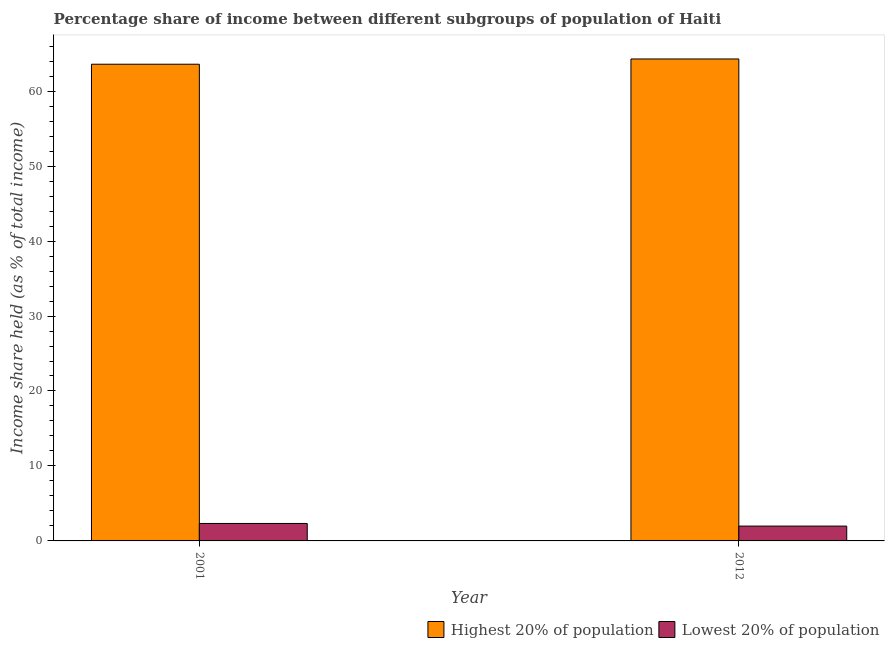How many bars are there on the 2nd tick from the left?
Provide a succinct answer. 2. How many bars are there on the 2nd tick from the right?
Provide a succinct answer. 2. What is the label of the 2nd group of bars from the left?
Your answer should be compact. 2012. In how many cases, is the number of bars for a given year not equal to the number of legend labels?
Offer a terse response. 0. What is the income share held by lowest 20% of the population in 2001?
Keep it short and to the point. 2.33. Across all years, what is the maximum income share held by lowest 20% of the population?
Your answer should be very brief. 2.33. Across all years, what is the minimum income share held by highest 20% of the population?
Keep it short and to the point. 63.59. In which year was the income share held by lowest 20% of the population maximum?
Your answer should be compact. 2001. In which year was the income share held by highest 20% of the population minimum?
Your answer should be compact. 2001. What is the total income share held by highest 20% of the population in the graph?
Your answer should be very brief. 127.88. What is the difference between the income share held by highest 20% of the population in 2001 and that in 2012?
Make the answer very short. -0.7. What is the difference between the income share held by lowest 20% of the population in 2001 and the income share held by highest 20% of the population in 2012?
Your response must be concise. 0.35. What is the average income share held by lowest 20% of the population per year?
Provide a succinct answer. 2.16. In the year 2012, what is the difference between the income share held by lowest 20% of the population and income share held by highest 20% of the population?
Keep it short and to the point. 0. What is the ratio of the income share held by highest 20% of the population in 2001 to that in 2012?
Provide a short and direct response. 0.99. In how many years, is the income share held by lowest 20% of the population greater than the average income share held by lowest 20% of the population taken over all years?
Your answer should be compact. 1. What does the 1st bar from the left in 2012 represents?
Offer a very short reply. Highest 20% of population. What does the 2nd bar from the right in 2001 represents?
Keep it short and to the point. Highest 20% of population. What is the difference between two consecutive major ticks on the Y-axis?
Make the answer very short. 10. Does the graph contain any zero values?
Offer a terse response. No. Does the graph contain grids?
Your answer should be compact. No. How many legend labels are there?
Provide a succinct answer. 2. What is the title of the graph?
Your answer should be very brief. Percentage share of income between different subgroups of population of Haiti. Does "current US$" appear as one of the legend labels in the graph?
Make the answer very short. No. What is the label or title of the Y-axis?
Provide a succinct answer. Income share held (as % of total income). What is the Income share held (as % of total income) of Highest 20% of population in 2001?
Give a very brief answer. 63.59. What is the Income share held (as % of total income) in Lowest 20% of population in 2001?
Offer a very short reply. 2.33. What is the Income share held (as % of total income) of Highest 20% of population in 2012?
Give a very brief answer. 64.29. What is the Income share held (as % of total income) in Lowest 20% of population in 2012?
Give a very brief answer. 1.98. Across all years, what is the maximum Income share held (as % of total income) in Highest 20% of population?
Make the answer very short. 64.29. Across all years, what is the maximum Income share held (as % of total income) in Lowest 20% of population?
Provide a succinct answer. 2.33. Across all years, what is the minimum Income share held (as % of total income) of Highest 20% of population?
Provide a short and direct response. 63.59. Across all years, what is the minimum Income share held (as % of total income) of Lowest 20% of population?
Offer a terse response. 1.98. What is the total Income share held (as % of total income) in Highest 20% of population in the graph?
Your answer should be compact. 127.88. What is the total Income share held (as % of total income) of Lowest 20% of population in the graph?
Offer a very short reply. 4.31. What is the difference between the Income share held (as % of total income) of Highest 20% of population in 2001 and that in 2012?
Keep it short and to the point. -0.7. What is the difference between the Income share held (as % of total income) in Lowest 20% of population in 2001 and that in 2012?
Make the answer very short. 0.35. What is the difference between the Income share held (as % of total income) of Highest 20% of population in 2001 and the Income share held (as % of total income) of Lowest 20% of population in 2012?
Provide a short and direct response. 61.61. What is the average Income share held (as % of total income) of Highest 20% of population per year?
Offer a very short reply. 63.94. What is the average Income share held (as % of total income) of Lowest 20% of population per year?
Ensure brevity in your answer.  2.15. In the year 2001, what is the difference between the Income share held (as % of total income) of Highest 20% of population and Income share held (as % of total income) of Lowest 20% of population?
Your answer should be compact. 61.26. In the year 2012, what is the difference between the Income share held (as % of total income) in Highest 20% of population and Income share held (as % of total income) in Lowest 20% of population?
Keep it short and to the point. 62.31. What is the ratio of the Income share held (as % of total income) in Lowest 20% of population in 2001 to that in 2012?
Offer a terse response. 1.18. What is the difference between the highest and the second highest Income share held (as % of total income) in Lowest 20% of population?
Your response must be concise. 0.35. What is the difference between the highest and the lowest Income share held (as % of total income) of Highest 20% of population?
Your answer should be compact. 0.7. 